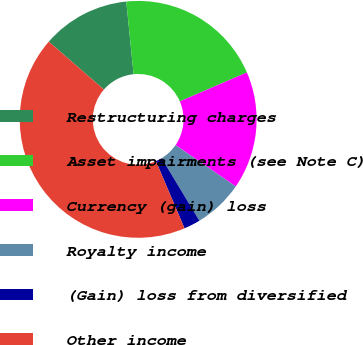Convert chart to OTSL. <chart><loc_0><loc_0><loc_500><loc_500><pie_chart><fcel>Restructuring charges<fcel>Asset impairments (see Note C)<fcel>Currency (gain) loss<fcel>Royalty income<fcel>(Gain) loss from diversified<fcel>Other income<nl><fcel>12.01%<fcel>20.12%<fcel>16.07%<fcel>6.76%<fcel>2.25%<fcel>42.79%<nl></chart> 